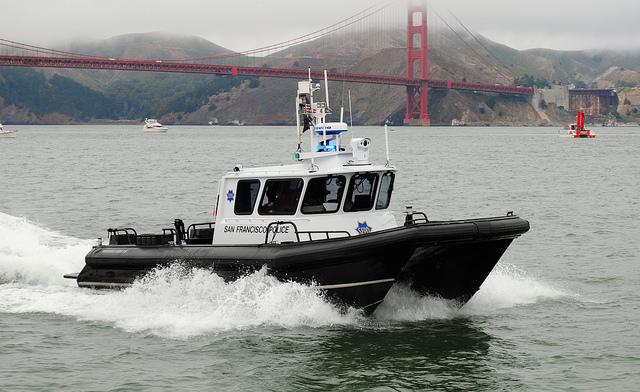What color is the body of this police boat?

Choices:
A) blue
B) green
C) black
D) white black 